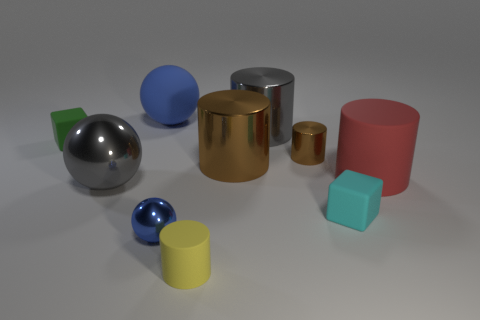Are there any red rubber cylinders on the left side of the tiny blue sphere? no 